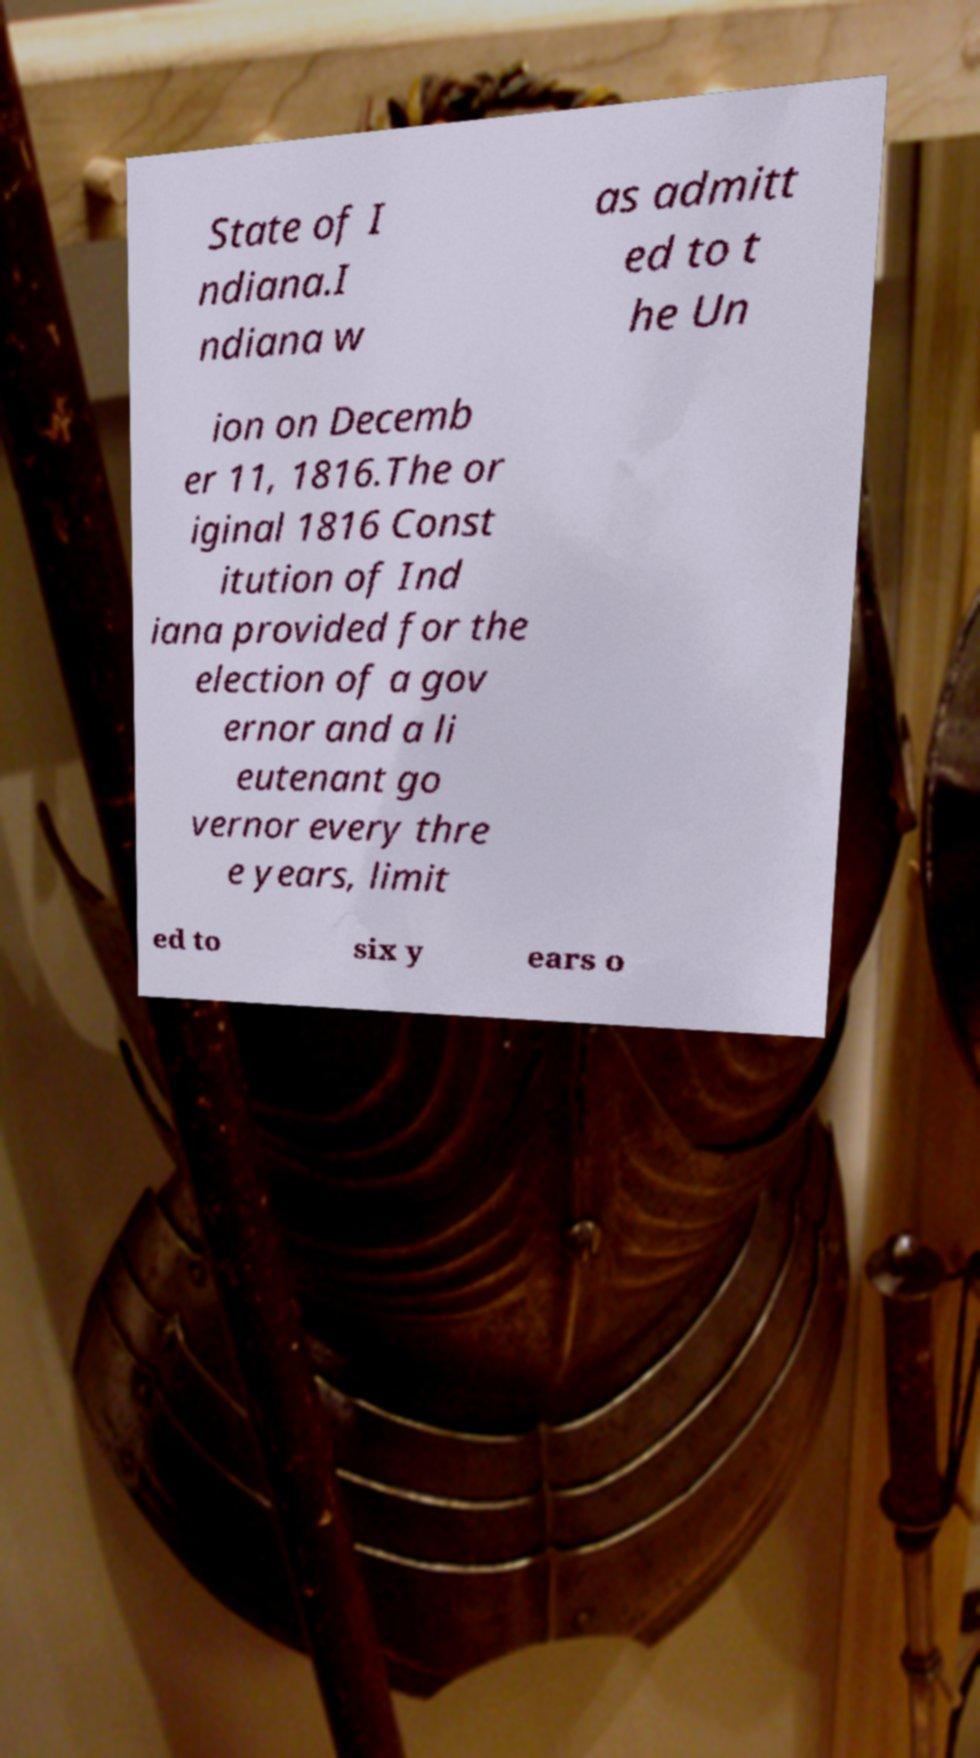Please read and relay the text visible in this image. What does it say? State of I ndiana.I ndiana w as admitt ed to t he Un ion on Decemb er 11, 1816.The or iginal 1816 Const itution of Ind iana provided for the election of a gov ernor and a li eutenant go vernor every thre e years, limit ed to six y ears o 